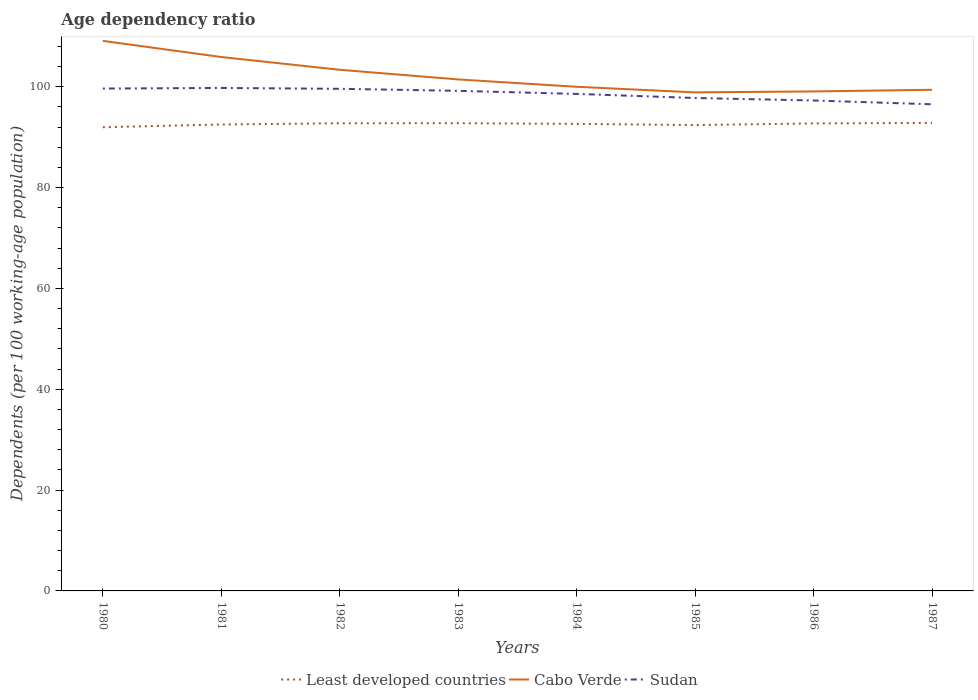How many different coloured lines are there?
Your response must be concise. 3. Across all years, what is the maximum age dependency ratio in in Cabo Verde?
Keep it short and to the point. 98.88. What is the total age dependency ratio in in Cabo Verde in the graph?
Your answer should be very brief. 1.91. What is the difference between the highest and the second highest age dependency ratio in in Least developed countries?
Your answer should be compact. 0.85. What is the difference between the highest and the lowest age dependency ratio in in Sudan?
Provide a short and direct response. 5. Is the age dependency ratio in in Sudan strictly greater than the age dependency ratio in in Least developed countries over the years?
Your answer should be compact. No. Are the values on the major ticks of Y-axis written in scientific E-notation?
Make the answer very short. No. Where does the legend appear in the graph?
Provide a succinct answer. Bottom center. How many legend labels are there?
Your response must be concise. 3. What is the title of the graph?
Ensure brevity in your answer.  Age dependency ratio. Does "Isle of Man" appear as one of the legend labels in the graph?
Your answer should be very brief. No. What is the label or title of the X-axis?
Make the answer very short. Years. What is the label or title of the Y-axis?
Keep it short and to the point. Dependents (per 100 working-age population). What is the Dependents (per 100 working-age population) in Least developed countries in 1980?
Ensure brevity in your answer.  91.97. What is the Dependents (per 100 working-age population) in Cabo Verde in 1980?
Make the answer very short. 109.09. What is the Dependents (per 100 working-age population) in Sudan in 1980?
Your answer should be very brief. 99.63. What is the Dependents (per 100 working-age population) of Least developed countries in 1981?
Keep it short and to the point. 92.51. What is the Dependents (per 100 working-age population) of Cabo Verde in 1981?
Ensure brevity in your answer.  105.89. What is the Dependents (per 100 working-age population) in Sudan in 1981?
Provide a short and direct response. 99.75. What is the Dependents (per 100 working-age population) of Least developed countries in 1982?
Your answer should be very brief. 92.75. What is the Dependents (per 100 working-age population) of Cabo Verde in 1982?
Make the answer very short. 103.36. What is the Dependents (per 100 working-age population) of Sudan in 1982?
Keep it short and to the point. 99.58. What is the Dependents (per 100 working-age population) in Least developed countries in 1983?
Your answer should be compact. 92.76. What is the Dependents (per 100 working-age population) of Cabo Verde in 1983?
Keep it short and to the point. 101.44. What is the Dependents (per 100 working-age population) in Sudan in 1983?
Make the answer very short. 99.18. What is the Dependents (per 100 working-age population) in Least developed countries in 1984?
Your response must be concise. 92.63. What is the Dependents (per 100 working-age population) of Cabo Verde in 1984?
Your answer should be compact. 99.98. What is the Dependents (per 100 working-age population) in Sudan in 1984?
Your answer should be very brief. 98.57. What is the Dependents (per 100 working-age population) in Least developed countries in 1985?
Keep it short and to the point. 92.39. What is the Dependents (per 100 working-age population) of Cabo Verde in 1985?
Offer a terse response. 98.88. What is the Dependents (per 100 working-age population) in Sudan in 1985?
Ensure brevity in your answer.  97.76. What is the Dependents (per 100 working-age population) of Least developed countries in 1986?
Your answer should be very brief. 92.72. What is the Dependents (per 100 working-age population) of Cabo Verde in 1986?
Offer a terse response. 99.06. What is the Dependents (per 100 working-age population) of Sudan in 1986?
Offer a terse response. 97.27. What is the Dependents (per 100 working-age population) in Least developed countries in 1987?
Make the answer very short. 92.81. What is the Dependents (per 100 working-age population) of Cabo Verde in 1987?
Your response must be concise. 99.39. What is the Dependents (per 100 working-age population) in Sudan in 1987?
Provide a short and direct response. 96.52. Across all years, what is the maximum Dependents (per 100 working-age population) in Least developed countries?
Provide a short and direct response. 92.81. Across all years, what is the maximum Dependents (per 100 working-age population) in Cabo Verde?
Your response must be concise. 109.09. Across all years, what is the maximum Dependents (per 100 working-age population) of Sudan?
Make the answer very short. 99.75. Across all years, what is the minimum Dependents (per 100 working-age population) in Least developed countries?
Your answer should be very brief. 91.97. Across all years, what is the minimum Dependents (per 100 working-age population) in Cabo Verde?
Offer a terse response. 98.88. Across all years, what is the minimum Dependents (per 100 working-age population) in Sudan?
Ensure brevity in your answer.  96.52. What is the total Dependents (per 100 working-age population) in Least developed countries in the graph?
Your answer should be compact. 740.54. What is the total Dependents (per 100 working-age population) in Cabo Verde in the graph?
Offer a very short reply. 817.08. What is the total Dependents (per 100 working-age population) in Sudan in the graph?
Your response must be concise. 788.27. What is the difference between the Dependents (per 100 working-age population) of Least developed countries in 1980 and that in 1981?
Your response must be concise. -0.54. What is the difference between the Dependents (per 100 working-age population) in Cabo Verde in 1980 and that in 1981?
Offer a very short reply. 3.2. What is the difference between the Dependents (per 100 working-age population) in Sudan in 1980 and that in 1981?
Your response must be concise. -0.12. What is the difference between the Dependents (per 100 working-age population) in Least developed countries in 1980 and that in 1982?
Provide a succinct answer. -0.78. What is the difference between the Dependents (per 100 working-age population) in Cabo Verde in 1980 and that in 1982?
Offer a very short reply. 5.73. What is the difference between the Dependents (per 100 working-age population) in Sudan in 1980 and that in 1982?
Provide a succinct answer. 0.05. What is the difference between the Dependents (per 100 working-age population) in Least developed countries in 1980 and that in 1983?
Give a very brief answer. -0.8. What is the difference between the Dependents (per 100 working-age population) of Cabo Verde in 1980 and that in 1983?
Make the answer very short. 7.64. What is the difference between the Dependents (per 100 working-age population) of Sudan in 1980 and that in 1983?
Provide a succinct answer. 0.45. What is the difference between the Dependents (per 100 working-age population) in Least developed countries in 1980 and that in 1984?
Ensure brevity in your answer.  -0.66. What is the difference between the Dependents (per 100 working-age population) in Cabo Verde in 1980 and that in 1984?
Your answer should be compact. 9.1. What is the difference between the Dependents (per 100 working-age population) of Sudan in 1980 and that in 1984?
Ensure brevity in your answer.  1.06. What is the difference between the Dependents (per 100 working-age population) in Least developed countries in 1980 and that in 1985?
Your answer should be compact. -0.43. What is the difference between the Dependents (per 100 working-age population) in Cabo Verde in 1980 and that in 1985?
Keep it short and to the point. 10.21. What is the difference between the Dependents (per 100 working-age population) in Sudan in 1980 and that in 1985?
Ensure brevity in your answer.  1.87. What is the difference between the Dependents (per 100 working-age population) in Least developed countries in 1980 and that in 1986?
Give a very brief answer. -0.75. What is the difference between the Dependents (per 100 working-age population) in Cabo Verde in 1980 and that in 1986?
Your answer should be very brief. 10.03. What is the difference between the Dependents (per 100 working-age population) of Sudan in 1980 and that in 1986?
Your response must be concise. 2.37. What is the difference between the Dependents (per 100 working-age population) of Least developed countries in 1980 and that in 1987?
Your answer should be compact. -0.85. What is the difference between the Dependents (per 100 working-age population) of Cabo Verde in 1980 and that in 1987?
Provide a succinct answer. 9.7. What is the difference between the Dependents (per 100 working-age population) in Sudan in 1980 and that in 1987?
Provide a succinct answer. 3.12. What is the difference between the Dependents (per 100 working-age population) of Least developed countries in 1981 and that in 1982?
Keep it short and to the point. -0.24. What is the difference between the Dependents (per 100 working-age population) of Cabo Verde in 1981 and that in 1982?
Provide a short and direct response. 2.53. What is the difference between the Dependents (per 100 working-age population) of Sudan in 1981 and that in 1982?
Give a very brief answer. 0.17. What is the difference between the Dependents (per 100 working-age population) of Least developed countries in 1981 and that in 1983?
Offer a very short reply. -0.26. What is the difference between the Dependents (per 100 working-age population) of Cabo Verde in 1981 and that in 1983?
Your answer should be very brief. 4.44. What is the difference between the Dependents (per 100 working-age population) of Sudan in 1981 and that in 1983?
Offer a terse response. 0.57. What is the difference between the Dependents (per 100 working-age population) in Least developed countries in 1981 and that in 1984?
Provide a succinct answer. -0.12. What is the difference between the Dependents (per 100 working-age population) in Cabo Verde in 1981 and that in 1984?
Your answer should be very brief. 5.9. What is the difference between the Dependents (per 100 working-age population) in Sudan in 1981 and that in 1984?
Your answer should be very brief. 1.18. What is the difference between the Dependents (per 100 working-age population) of Least developed countries in 1981 and that in 1985?
Ensure brevity in your answer.  0.11. What is the difference between the Dependents (per 100 working-age population) of Cabo Verde in 1981 and that in 1985?
Keep it short and to the point. 7.01. What is the difference between the Dependents (per 100 working-age population) of Sudan in 1981 and that in 1985?
Keep it short and to the point. 1.99. What is the difference between the Dependents (per 100 working-age population) in Least developed countries in 1981 and that in 1986?
Your answer should be very brief. -0.21. What is the difference between the Dependents (per 100 working-age population) in Cabo Verde in 1981 and that in 1986?
Keep it short and to the point. 6.83. What is the difference between the Dependents (per 100 working-age population) in Sudan in 1981 and that in 1986?
Provide a short and direct response. 2.49. What is the difference between the Dependents (per 100 working-age population) in Least developed countries in 1981 and that in 1987?
Provide a succinct answer. -0.31. What is the difference between the Dependents (per 100 working-age population) of Cabo Verde in 1981 and that in 1987?
Your answer should be compact. 6.5. What is the difference between the Dependents (per 100 working-age population) of Sudan in 1981 and that in 1987?
Ensure brevity in your answer.  3.24. What is the difference between the Dependents (per 100 working-age population) of Least developed countries in 1982 and that in 1983?
Give a very brief answer. -0.01. What is the difference between the Dependents (per 100 working-age population) in Cabo Verde in 1982 and that in 1983?
Your answer should be compact. 1.91. What is the difference between the Dependents (per 100 working-age population) of Sudan in 1982 and that in 1983?
Provide a succinct answer. 0.4. What is the difference between the Dependents (per 100 working-age population) of Least developed countries in 1982 and that in 1984?
Give a very brief answer. 0.12. What is the difference between the Dependents (per 100 working-age population) in Cabo Verde in 1982 and that in 1984?
Offer a very short reply. 3.37. What is the difference between the Dependents (per 100 working-age population) of Sudan in 1982 and that in 1984?
Your answer should be very brief. 1.01. What is the difference between the Dependents (per 100 working-age population) in Least developed countries in 1982 and that in 1985?
Keep it short and to the point. 0.35. What is the difference between the Dependents (per 100 working-age population) of Cabo Verde in 1982 and that in 1985?
Make the answer very short. 4.48. What is the difference between the Dependents (per 100 working-age population) of Sudan in 1982 and that in 1985?
Your answer should be very brief. 1.82. What is the difference between the Dependents (per 100 working-age population) in Least developed countries in 1982 and that in 1986?
Ensure brevity in your answer.  0.03. What is the difference between the Dependents (per 100 working-age population) in Cabo Verde in 1982 and that in 1986?
Ensure brevity in your answer.  4.3. What is the difference between the Dependents (per 100 working-age population) in Sudan in 1982 and that in 1986?
Give a very brief answer. 2.32. What is the difference between the Dependents (per 100 working-age population) in Least developed countries in 1982 and that in 1987?
Provide a succinct answer. -0.07. What is the difference between the Dependents (per 100 working-age population) of Cabo Verde in 1982 and that in 1987?
Offer a very short reply. 3.97. What is the difference between the Dependents (per 100 working-age population) of Sudan in 1982 and that in 1987?
Your answer should be compact. 3.07. What is the difference between the Dependents (per 100 working-age population) in Least developed countries in 1983 and that in 1984?
Ensure brevity in your answer.  0.13. What is the difference between the Dependents (per 100 working-age population) in Cabo Verde in 1983 and that in 1984?
Make the answer very short. 1.46. What is the difference between the Dependents (per 100 working-age population) of Sudan in 1983 and that in 1984?
Your answer should be compact. 0.61. What is the difference between the Dependents (per 100 working-age population) of Least developed countries in 1983 and that in 1985?
Offer a terse response. 0.37. What is the difference between the Dependents (per 100 working-age population) in Cabo Verde in 1983 and that in 1985?
Your answer should be very brief. 2.57. What is the difference between the Dependents (per 100 working-age population) in Sudan in 1983 and that in 1985?
Provide a succinct answer. 1.42. What is the difference between the Dependents (per 100 working-age population) of Least developed countries in 1983 and that in 1986?
Your answer should be very brief. 0.04. What is the difference between the Dependents (per 100 working-age population) of Cabo Verde in 1983 and that in 1986?
Offer a terse response. 2.38. What is the difference between the Dependents (per 100 working-age population) of Sudan in 1983 and that in 1986?
Give a very brief answer. 1.91. What is the difference between the Dependents (per 100 working-age population) of Least developed countries in 1983 and that in 1987?
Provide a short and direct response. -0.05. What is the difference between the Dependents (per 100 working-age population) in Cabo Verde in 1983 and that in 1987?
Make the answer very short. 2.05. What is the difference between the Dependents (per 100 working-age population) of Sudan in 1983 and that in 1987?
Ensure brevity in your answer.  2.66. What is the difference between the Dependents (per 100 working-age population) of Least developed countries in 1984 and that in 1985?
Your answer should be compact. 0.24. What is the difference between the Dependents (per 100 working-age population) in Cabo Verde in 1984 and that in 1985?
Your response must be concise. 1.11. What is the difference between the Dependents (per 100 working-age population) in Sudan in 1984 and that in 1985?
Give a very brief answer. 0.81. What is the difference between the Dependents (per 100 working-age population) of Least developed countries in 1984 and that in 1986?
Offer a terse response. -0.09. What is the difference between the Dependents (per 100 working-age population) of Cabo Verde in 1984 and that in 1986?
Keep it short and to the point. 0.92. What is the difference between the Dependents (per 100 working-age population) in Sudan in 1984 and that in 1986?
Provide a succinct answer. 1.3. What is the difference between the Dependents (per 100 working-age population) in Least developed countries in 1984 and that in 1987?
Provide a succinct answer. -0.19. What is the difference between the Dependents (per 100 working-age population) in Cabo Verde in 1984 and that in 1987?
Keep it short and to the point. 0.59. What is the difference between the Dependents (per 100 working-age population) in Sudan in 1984 and that in 1987?
Provide a short and direct response. 2.05. What is the difference between the Dependents (per 100 working-age population) in Least developed countries in 1985 and that in 1986?
Offer a very short reply. -0.33. What is the difference between the Dependents (per 100 working-age population) of Cabo Verde in 1985 and that in 1986?
Provide a short and direct response. -0.18. What is the difference between the Dependents (per 100 working-age population) of Sudan in 1985 and that in 1986?
Provide a short and direct response. 0.5. What is the difference between the Dependents (per 100 working-age population) in Least developed countries in 1985 and that in 1987?
Your answer should be compact. -0.42. What is the difference between the Dependents (per 100 working-age population) of Cabo Verde in 1985 and that in 1987?
Your answer should be compact. -0.51. What is the difference between the Dependents (per 100 working-age population) of Sudan in 1985 and that in 1987?
Provide a short and direct response. 1.25. What is the difference between the Dependents (per 100 working-age population) of Least developed countries in 1986 and that in 1987?
Offer a terse response. -0.1. What is the difference between the Dependents (per 100 working-age population) of Cabo Verde in 1986 and that in 1987?
Provide a short and direct response. -0.33. What is the difference between the Dependents (per 100 working-age population) of Sudan in 1986 and that in 1987?
Provide a succinct answer. 0.75. What is the difference between the Dependents (per 100 working-age population) of Least developed countries in 1980 and the Dependents (per 100 working-age population) of Cabo Verde in 1981?
Your answer should be very brief. -13.92. What is the difference between the Dependents (per 100 working-age population) in Least developed countries in 1980 and the Dependents (per 100 working-age population) in Sudan in 1981?
Ensure brevity in your answer.  -7.79. What is the difference between the Dependents (per 100 working-age population) in Cabo Verde in 1980 and the Dependents (per 100 working-age population) in Sudan in 1981?
Make the answer very short. 9.33. What is the difference between the Dependents (per 100 working-age population) in Least developed countries in 1980 and the Dependents (per 100 working-age population) in Cabo Verde in 1982?
Offer a terse response. -11.39. What is the difference between the Dependents (per 100 working-age population) of Least developed countries in 1980 and the Dependents (per 100 working-age population) of Sudan in 1982?
Your answer should be compact. -7.62. What is the difference between the Dependents (per 100 working-age population) in Cabo Verde in 1980 and the Dependents (per 100 working-age population) in Sudan in 1982?
Give a very brief answer. 9.5. What is the difference between the Dependents (per 100 working-age population) in Least developed countries in 1980 and the Dependents (per 100 working-age population) in Cabo Verde in 1983?
Your response must be concise. -9.48. What is the difference between the Dependents (per 100 working-age population) of Least developed countries in 1980 and the Dependents (per 100 working-age population) of Sudan in 1983?
Keep it short and to the point. -7.21. What is the difference between the Dependents (per 100 working-age population) in Cabo Verde in 1980 and the Dependents (per 100 working-age population) in Sudan in 1983?
Offer a terse response. 9.91. What is the difference between the Dependents (per 100 working-age population) in Least developed countries in 1980 and the Dependents (per 100 working-age population) in Cabo Verde in 1984?
Keep it short and to the point. -8.02. What is the difference between the Dependents (per 100 working-age population) in Least developed countries in 1980 and the Dependents (per 100 working-age population) in Sudan in 1984?
Offer a very short reply. -6.6. What is the difference between the Dependents (per 100 working-age population) of Cabo Verde in 1980 and the Dependents (per 100 working-age population) of Sudan in 1984?
Make the answer very short. 10.52. What is the difference between the Dependents (per 100 working-age population) of Least developed countries in 1980 and the Dependents (per 100 working-age population) of Cabo Verde in 1985?
Provide a short and direct response. -6.91. What is the difference between the Dependents (per 100 working-age population) of Least developed countries in 1980 and the Dependents (per 100 working-age population) of Sudan in 1985?
Give a very brief answer. -5.8. What is the difference between the Dependents (per 100 working-age population) of Cabo Verde in 1980 and the Dependents (per 100 working-age population) of Sudan in 1985?
Your answer should be compact. 11.32. What is the difference between the Dependents (per 100 working-age population) of Least developed countries in 1980 and the Dependents (per 100 working-age population) of Cabo Verde in 1986?
Ensure brevity in your answer.  -7.09. What is the difference between the Dependents (per 100 working-age population) of Least developed countries in 1980 and the Dependents (per 100 working-age population) of Sudan in 1986?
Your answer should be very brief. -5.3. What is the difference between the Dependents (per 100 working-age population) of Cabo Verde in 1980 and the Dependents (per 100 working-age population) of Sudan in 1986?
Provide a succinct answer. 11.82. What is the difference between the Dependents (per 100 working-age population) in Least developed countries in 1980 and the Dependents (per 100 working-age population) in Cabo Verde in 1987?
Offer a very short reply. -7.42. What is the difference between the Dependents (per 100 working-age population) in Least developed countries in 1980 and the Dependents (per 100 working-age population) in Sudan in 1987?
Provide a succinct answer. -4.55. What is the difference between the Dependents (per 100 working-age population) of Cabo Verde in 1980 and the Dependents (per 100 working-age population) of Sudan in 1987?
Provide a short and direct response. 12.57. What is the difference between the Dependents (per 100 working-age population) in Least developed countries in 1981 and the Dependents (per 100 working-age population) in Cabo Verde in 1982?
Your answer should be compact. -10.85. What is the difference between the Dependents (per 100 working-age population) in Least developed countries in 1981 and the Dependents (per 100 working-age population) in Sudan in 1982?
Your response must be concise. -7.08. What is the difference between the Dependents (per 100 working-age population) of Cabo Verde in 1981 and the Dependents (per 100 working-age population) of Sudan in 1982?
Keep it short and to the point. 6.3. What is the difference between the Dependents (per 100 working-age population) of Least developed countries in 1981 and the Dependents (per 100 working-age population) of Cabo Verde in 1983?
Give a very brief answer. -8.94. What is the difference between the Dependents (per 100 working-age population) of Least developed countries in 1981 and the Dependents (per 100 working-age population) of Sudan in 1983?
Your answer should be very brief. -6.67. What is the difference between the Dependents (per 100 working-age population) of Cabo Verde in 1981 and the Dependents (per 100 working-age population) of Sudan in 1983?
Ensure brevity in your answer.  6.71. What is the difference between the Dependents (per 100 working-age population) of Least developed countries in 1981 and the Dependents (per 100 working-age population) of Cabo Verde in 1984?
Keep it short and to the point. -7.47. What is the difference between the Dependents (per 100 working-age population) in Least developed countries in 1981 and the Dependents (per 100 working-age population) in Sudan in 1984?
Offer a terse response. -6.06. What is the difference between the Dependents (per 100 working-age population) of Cabo Verde in 1981 and the Dependents (per 100 working-age population) of Sudan in 1984?
Offer a very short reply. 7.32. What is the difference between the Dependents (per 100 working-age population) in Least developed countries in 1981 and the Dependents (per 100 working-age population) in Cabo Verde in 1985?
Provide a succinct answer. -6.37. What is the difference between the Dependents (per 100 working-age population) in Least developed countries in 1981 and the Dependents (per 100 working-age population) in Sudan in 1985?
Keep it short and to the point. -5.25. What is the difference between the Dependents (per 100 working-age population) in Cabo Verde in 1981 and the Dependents (per 100 working-age population) in Sudan in 1985?
Your response must be concise. 8.13. What is the difference between the Dependents (per 100 working-age population) in Least developed countries in 1981 and the Dependents (per 100 working-age population) in Cabo Verde in 1986?
Your answer should be very brief. -6.55. What is the difference between the Dependents (per 100 working-age population) of Least developed countries in 1981 and the Dependents (per 100 working-age population) of Sudan in 1986?
Offer a terse response. -4.76. What is the difference between the Dependents (per 100 working-age population) of Cabo Verde in 1981 and the Dependents (per 100 working-age population) of Sudan in 1986?
Offer a very short reply. 8.62. What is the difference between the Dependents (per 100 working-age population) of Least developed countries in 1981 and the Dependents (per 100 working-age population) of Cabo Verde in 1987?
Make the answer very short. -6.88. What is the difference between the Dependents (per 100 working-age population) in Least developed countries in 1981 and the Dependents (per 100 working-age population) in Sudan in 1987?
Your answer should be compact. -4.01. What is the difference between the Dependents (per 100 working-age population) in Cabo Verde in 1981 and the Dependents (per 100 working-age population) in Sudan in 1987?
Give a very brief answer. 9.37. What is the difference between the Dependents (per 100 working-age population) in Least developed countries in 1982 and the Dependents (per 100 working-age population) in Cabo Verde in 1983?
Your response must be concise. -8.69. What is the difference between the Dependents (per 100 working-age population) in Least developed countries in 1982 and the Dependents (per 100 working-age population) in Sudan in 1983?
Provide a short and direct response. -6.43. What is the difference between the Dependents (per 100 working-age population) of Cabo Verde in 1982 and the Dependents (per 100 working-age population) of Sudan in 1983?
Provide a succinct answer. 4.17. What is the difference between the Dependents (per 100 working-age population) of Least developed countries in 1982 and the Dependents (per 100 working-age population) of Cabo Verde in 1984?
Keep it short and to the point. -7.23. What is the difference between the Dependents (per 100 working-age population) in Least developed countries in 1982 and the Dependents (per 100 working-age population) in Sudan in 1984?
Your answer should be very brief. -5.82. What is the difference between the Dependents (per 100 working-age population) in Cabo Verde in 1982 and the Dependents (per 100 working-age population) in Sudan in 1984?
Offer a very short reply. 4.79. What is the difference between the Dependents (per 100 working-age population) of Least developed countries in 1982 and the Dependents (per 100 working-age population) of Cabo Verde in 1985?
Make the answer very short. -6.13. What is the difference between the Dependents (per 100 working-age population) of Least developed countries in 1982 and the Dependents (per 100 working-age population) of Sudan in 1985?
Ensure brevity in your answer.  -5.01. What is the difference between the Dependents (per 100 working-age population) of Cabo Verde in 1982 and the Dependents (per 100 working-age population) of Sudan in 1985?
Make the answer very short. 5.59. What is the difference between the Dependents (per 100 working-age population) of Least developed countries in 1982 and the Dependents (per 100 working-age population) of Cabo Verde in 1986?
Provide a short and direct response. -6.31. What is the difference between the Dependents (per 100 working-age population) in Least developed countries in 1982 and the Dependents (per 100 working-age population) in Sudan in 1986?
Your response must be concise. -4.52. What is the difference between the Dependents (per 100 working-age population) of Cabo Verde in 1982 and the Dependents (per 100 working-age population) of Sudan in 1986?
Give a very brief answer. 6.09. What is the difference between the Dependents (per 100 working-age population) of Least developed countries in 1982 and the Dependents (per 100 working-age population) of Cabo Verde in 1987?
Keep it short and to the point. -6.64. What is the difference between the Dependents (per 100 working-age population) in Least developed countries in 1982 and the Dependents (per 100 working-age population) in Sudan in 1987?
Give a very brief answer. -3.77. What is the difference between the Dependents (per 100 working-age population) of Cabo Verde in 1982 and the Dependents (per 100 working-age population) of Sudan in 1987?
Your response must be concise. 6.84. What is the difference between the Dependents (per 100 working-age population) of Least developed countries in 1983 and the Dependents (per 100 working-age population) of Cabo Verde in 1984?
Provide a short and direct response. -7.22. What is the difference between the Dependents (per 100 working-age population) in Least developed countries in 1983 and the Dependents (per 100 working-age population) in Sudan in 1984?
Your answer should be compact. -5.81. What is the difference between the Dependents (per 100 working-age population) in Cabo Verde in 1983 and the Dependents (per 100 working-age population) in Sudan in 1984?
Ensure brevity in your answer.  2.87. What is the difference between the Dependents (per 100 working-age population) of Least developed countries in 1983 and the Dependents (per 100 working-age population) of Cabo Verde in 1985?
Your answer should be very brief. -6.11. What is the difference between the Dependents (per 100 working-age population) of Least developed countries in 1983 and the Dependents (per 100 working-age population) of Sudan in 1985?
Offer a very short reply. -5. What is the difference between the Dependents (per 100 working-age population) of Cabo Verde in 1983 and the Dependents (per 100 working-age population) of Sudan in 1985?
Provide a short and direct response. 3.68. What is the difference between the Dependents (per 100 working-age population) of Least developed countries in 1983 and the Dependents (per 100 working-age population) of Cabo Verde in 1986?
Offer a very short reply. -6.3. What is the difference between the Dependents (per 100 working-age population) in Least developed countries in 1983 and the Dependents (per 100 working-age population) in Sudan in 1986?
Provide a short and direct response. -4.5. What is the difference between the Dependents (per 100 working-age population) in Cabo Verde in 1983 and the Dependents (per 100 working-age population) in Sudan in 1986?
Provide a succinct answer. 4.18. What is the difference between the Dependents (per 100 working-age population) in Least developed countries in 1983 and the Dependents (per 100 working-age population) in Cabo Verde in 1987?
Make the answer very short. -6.63. What is the difference between the Dependents (per 100 working-age population) in Least developed countries in 1983 and the Dependents (per 100 working-age population) in Sudan in 1987?
Keep it short and to the point. -3.75. What is the difference between the Dependents (per 100 working-age population) in Cabo Verde in 1983 and the Dependents (per 100 working-age population) in Sudan in 1987?
Keep it short and to the point. 4.93. What is the difference between the Dependents (per 100 working-age population) of Least developed countries in 1984 and the Dependents (per 100 working-age population) of Cabo Verde in 1985?
Keep it short and to the point. -6.25. What is the difference between the Dependents (per 100 working-age population) of Least developed countries in 1984 and the Dependents (per 100 working-age population) of Sudan in 1985?
Your answer should be very brief. -5.13. What is the difference between the Dependents (per 100 working-age population) in Cabo Verde in 1984 and the Dependents (per 100 working-age population) in Sudan in 1985?
Your answer should be very brief. 2.22. What is the difference between the Dependents (per 100 working-age population) of Least developed countries in 1984 and the Dependents (per 100 working-age population) of Cabo Verde in 1986?
Your answer should be very brief. -6.43. What is the difference between the Dependents (per 100 working-age population) of Least developed countries in 1984 and the Dependents (per 100 working-age population) of Sudan in 1986?
Give a very brief answer. -4.64. What is the difference between the Dependents (per 100 working-age population) in Cabo Verde in 1984 and the Dependents (per 100 working-age population) in Sudan in 1986?
Your answer should be very brief. 2.72. What is the difference between the Dependents (per 100 working-age population) of Least developed countries in 1984 and the Dependents (per 100 working-age population) of Cabo Verde in 1987?
Give a very brief answer. -6.76. What is the difference between the Dependents (per 100 working-age population) in Least developed countries in 1984 and the Dependents (per 100 working-age population) in Sudan in 1987?
Provide a short and direct response. -3.89. What is the difference between the Dependents (per 100 working-age population) of Cabo Verde in 1984 and the Dependents (per 100 working-age population) of Sudan in 1987?
Your answer should be very brief. 3.47. What is the difference between the Dependents (per 100 working-age population) of Least developed countries in 1985 and the Dependents (per 100 working-age population) of Cabo Verde in 1986?
Your response must be concise. -6.67. What is the difference between the Dependents (per 100 working-age population) in Least developed countries in 1985 and the Dependents (per 100 working-age population) in Sudan in 1986?
Make the answer very short. -4.87. What is the difference between the Dependents (per 100 working-age population) in Cabo Verde in 1985 and the Dependents (per 100 working-age population) in Sudan in 1986?
Offer a very short reply. 1.61. What is the difference between the Dependents (per 100 working-age population) of Least developed countries in 1985 and the Dependents (per 100 working-age population) of Cabo Verde in 1987?
Offer a very short reply. -7. What is the difference between the Dependents (per 100 working-age population) of Least developed countries in 1985 and the Dependents (per 100 working-age population) of Sudan in 1987?
Offer a terse response. -4.12. What is the difference between the Dependents (per 100 working-age population) of Cabo Verde in 1985 and the Dependents (per 100 working-age population) of Sudan in 1987?
Keep it short and to the point. 2.36. What is the difference between the Dependents (per 100 working-age population) of Least developed countries in 1986 and the Dependents (per 100 working-age population) of Cabo Verde in 1987?
Your answer should be compact. -6.67. What is the difference between the Dependents (per 100 working-age population) of Least developed countries in 1986 and the Dependents (per 100 working-age population) of Sudan in 1987?
Your answer should be compact. -3.8. What is the difference between the Dependents (per 100 working-age population) of Cabo Verde in 1986 and the Dependents (per 100 working-age population) of Sudan in 1987?
Offer a very short reply. 2.54. What is the average Dependents (per 100 working-age population) of Least developed countries per year?
Provide a succinct answer. 92.57. What is the average Dependents (per 100 working-age population) of Cabo Verde per year?
Your response must be concise. 102.13. What is the average Dependents (per 100 working-age population) in Sudan per year?
Provide a short and direct response. 98.53. In the year 1980, what is the difference between the Dependents (per 100 working-age population) of Least developed countries and Dependents (per 100 working-age population) of Cabo Verde?
Provide a succinct answer. -17.12. In the year 1980, what is the difference between the Dependents (per 100 working-age population) of Least developed countries and Dependents (per 100 working-age population) of Sudan?
Offer a terse response. -7.67. In the year 1980, what is the difference between the Dependents (per 100 working-age population) in Cabo Verde and Dependents (per 100 working-age population) in Sudan?
Your response must be concise. 9.45. In the year 1981, what is the difference between the Dependents (per 100 working-age population) of Least developed countries and Dependents (per 100 working-age population) of Cabo Verde?
Keep it short and to the point. -13.38. In the year 1981, what is the difference between the Dependents (per 100 working-age population) in Least developed countries and Dependents (per 100 working-age population) in Sudan?
Your answer should be very brief. -7.24. In the year 1981, what is the difference between the Dependents (per 100 working-age population) in Cabo Verde and Dependents (per 100 working-age population) in Sudan?
Keep it short and to the point. 6.13. In the year 1982, what is the difference between the Dependents (per 100 working-age population) in Least developed countries and Dependents (per 100 working-age population) in Cabo Verde?
Your response must be concise. -10.61. In the year 1982, what is the difference between the Dependents (per 100 working-age population) of Least developed countries and Dependents (per 100 working-age population) of Sudan?
Give a very brief answer. -6.84. In the year 1982, what is the difference between the Dependents (per 100 working-age population) of Cabo Verde and Dependents (per 100 working-age population) of Sudan?
Offer a terse response. 3.77. In the year 1983, what is the difference between the Dependents (per 100 working-age population) in Least developed countries and Dependents (per 100 working-age population) in Cabo Verde?
Keep it short and to the point. -8.68. In the year 1983, what is the difference between the Dependents (per 100 working-age population) of Least developed countries and Dependents (per 100 working-age population) of Sudan?
Provide a succinct answer. -6.42. In the year 1983, what is the difference between the Dependents (per 100 working-age population) of Cabo Verde and Dependents (per 100 working-age population) of Sudan?
Provide a succinct answer. 2.26. In the year 1984, what is the difference between the Dependents (per 100 working-age population) of Least developed countries and Dependents (per 100 working-age population) of Cabo Verde?
Your answer should be compact. -7.35. In the year 1984, what is the difference between the Dependents (per 100 working-age population) in Least developed countries and Dependents (per 100 working-age population) in Sudan?
Your answer should be very brief. -5.94. In the year 1984, what is the difference between the Dependents (per 100 working-age population) in Cabo Verde and Dependents (per 100 working-age population) in Sudan?
Provide a succinct answer. 1.41. In the year 1985, what is the difference between the Dependents (per 100 working-age population) in Least developed countries and Dependents (per 100 working-age population) in Cabo Verde?
Your answer should be compact. -6.48. In the year 1985, what is the difference between the Dependents (per 100 working-age population) of Least developed countries and Dependents (per 100 working-age population) of Sudan?
Offer a terse response. -5.37. In the year 1985, what is the difference between the Dependents (per 100 working-age population) in Cabo Verde and Dependents (per 100 working-age population) in Sudan?
Provide a short and direct response. 1.12. In the year 1986, what is the difference between the Dependents (per 100 working-age population) in Least developed countries and Dependents (per 100 working-age population) in Cabo Verde?
Offer a very short reply. -6.34. In the year 1986, what is the difference between the Dependents (per 100 working-age population) of Least developed countries and Dependents (per 100 working-age population) of Sudan?
Keep it short and to the point. -4.55. In the year 1986, what is the difference between the Dependents (per 100 working-age population) of Cabo Verde and Dependents (per 100 working-age population) of Sudan?
Your answer should be compact. 1.79. In the year 1987, what is the difference between the Dependents (per 100 working-age population) in Least developed countries and Dependents (per 100 working-age population) in Cabo Verde?
Provide a short and direct response. -6.57. In the year 1987, what is the difference between the Dependents (per 100 working-age population) in Least developed countries and Dependents (per 100 working-age population) in Sudan?
Give a very brief answer. -3.7. In the year 1987, what is the difference between the Dependents (per 100 working-age population) in Cabo Verde and Dependents (per 100 working-age population) in Sudan?
Provide a short and direct response. 2.87. What is the ratio of the Dependents (per 100 working-age population) in Cabo Verde in 1980 to that in 1981?
Provide a short and direct response. 1.03. What is the ratio of the Dependents (per 100 working-age population) of Sudan in 1980 to that in 1981?
Your answer should be very brief. 1. What is the ratio of the Dependents (per 100 working-age population) in Cabo Verde in 1980 to that in 1982?
Make the answer very short. 1.06. What is the ratio of the Dependents (per 100 working-age population) of Sudan in 1980 to that in 1982?
Offer a terse response. 1. What is the ratio of the Dependents (per 100 working-age population) in Cabo Verde in 1980 to that in 1983?
Offer a terse response. 1.08. What is the ratio of the Dependents (per 100 working-age population) of Sudan in 1980 to that in 1983?
Offer a very short reply. 1. What is the ratio of the Dependents (per 100 working-age population) in Cabo Verde in 1980 to that in 1984?
Keep it short and to the point. 1.09. What is the ratio of the Dependents (per 100 working-age population) of Sudan in 1980 to that in 1984?
Your answer should be compact. 1.01. What is the ratio of the Dependents (per 100 working-age population) of Cabo Verde in 1980 to that in 1985?
Keep it short and to the point. 1.1. What is the ratio of the Dependents (per 100 working-age population) of Sudan in 1980 to that in 1985?
Provide a short and direct response. 1.02. What is the ratio of the Dependents (per 100 working-age population) of Cabo Verde in 1980 to that in 1986?
Make the answer very short. 1.1. What is the ratio of the Dependents (per 100 working-age population) of Sudan in 1980 to that in 1986?
Provide a succinct answer. 1.02. What is the ratio of the Dependents (per 100 working-age population) of Least developed countries in 1980 to that in 1987?
Offer a very short reply. 0.99. What is the ratio of the Dependents (per 100 working-age population) in Cabo Verde in 1980 to that in 1987?
Your answer should be compact. 1.1. What is the ratio of the Dependents (per 100 working-age population) in Sudan in 1980 to that in 1987?
Ensure brevity in your answer.  1.03. What is the ratio of the Dependents (per 100 working-age population) of Least developed countries in 1981 to that in 1982?
Offer a terse response. 1. What is the ratio of the Dependents (per 100 working-age population) of Cabo Verde in 1981 to that in 1982?
Your answer should be compact. 1.02. What is the ratio of the Dependents (per 100 working-age population) in Sudan in 1981 to that in 1982?
Your answer should be very brief. 1. What is the ratio of the Dependents (per 100 working-age population) of Least developed countries in 1981 to that in 1983?
Make the answer very short. 1. What is the ratio of the Dependents (per 100 working-age population) of Cabo Verde in 1981 to that in 1983?
Provide a short and direct response. 1.04. What is the ratio of the Dependents (per 100 working-age population) of Least developed countries in 1981 to that in 1984?
Keep it short and to the point. 1. What is the ratio of the Dependents (per 100 working-age population) of Cabo Verde in 1981 to that in 1984?
Your answer should be very brief. 1.06. What is the ratio of the Dependents (per 100 working-age population) of Sudan in 1981 to that in 1984?
Provide a succinct answer. 1.01. What is the ratio of the Dependents (per 100 working-age population) of Least developed countries in 1981 to that in 1985?
Provide a short and direct response. 1. What is the ratio of the Dependents (per 100 working-age population) of Cabo Verde in 1981 to that in 1985?
Offer a very short reply. 1.07. What is the ratio of the Dependents (per 100 working-age population) of Sudan in 1981 to that in 1985?
Provide a short and direct response. 1.02. What is the ratio of the Dependents (per 100 working-age population) of Cabo Verde in 1981 to that in 1986?
Offer a terse response. 1.07. What is the ratio of the Dependents (per 100 working-age population) in Sudan in 1981 to that in 1986?
Ensure brevity in your answer.  1.03. What is the ratio of the Dependents (per 100 working-age population) in Cabo Verde in 1981 to that in 1987?
Your answer should be very brief. 1.07. What is the ratio of the Dependents (per 100 working-age population) of Sudan in 1981 to that in 1987?
Keep it short and to the point. 1.03. What is the ratio of the Dependents (per 100 working-age population) in Cabo Verde in 1982 to that in 1983?
Ensure brevity in your answer.  1.02. What is the ratio of the Dependents (per 100 working-age population) in Sudan in 1982 to that in 1983?
Provide a succinct answer. 1. What is the ratio of the Dependents (per 100 working-age population) of Least developed countries in 1982 to that in 1984?
Keep it short and to the point. 1. What is the ratio of the Dependents (per 100 working-age population) of Cabo Verde in 1982 to that in 1984?
Your answer should be very brief. 1.03. What is the ratio of the Dependents (per 100 working-age population) of Sudan in 1982 to that in 1984?
Give a very brief answer. 1.01. What is the ratio of the Dependents (per 100 working-age population) of Least developed countries in 1982 to that in 1985?
Give a very brief answer. 1. What is the ratio of the Dependents (per 100 working-age population) of Cabo Verde in 1982 to that in 1985?
Give a very brief answer. 1.05. What is the ratio of the Dependents (per 100 working-age population) of Sudan in 1982 to that in 1985?
Keep it short and to the point. 1.02. What is the ratio of the Dependents (per 100 working-age population) of Cabo Verde in 1982 to that in 1986?
Give a very brief answer. 1.04. What is the ratio of the Dependents (per 100 working-age population) in Sudan in 1982 to that in 1986?
Your answer should be very brief. 1.02. What is the ratio of the Dependents (per 100 working-age population) in Least developed countries in 1982 to that in 1987?
Provide a short and direct response. 1. What is the ratio of the Dependents (per 100 working-age population) in Cabo Verde in 1982 to that in 1987?
Offer a terse response. 1.04. What is the ratio of the Dependents (per 100 working-age population) in Sudan in 1982 to that in 1987?
Give a very brief answer. 1.03. What is the ratio of the Dependents (per 100 working-age population) in Least developed countries in 1983 to that in 1984?
Offer a very short reply. 1. What is the ratio of the Dependents (per 100 working-age population) of Cabo Verde in 1983 to that in 1984?
Your answer should be very brief. 1.01. What is the ratio of the Dependents (per 100 working-age population) in Sudan in 1983 to that in 1984?
Ensure brevity in your answer.  1.01. What is the ratio of the Dependents (per 100 working-age population) of Least developed countries in 1983 to that in 1985?
Offer a very short reply. 1. What is the ratio of the Dependents (per 100 working-age population) of Sudan in 1983 to that in 1985?
Your answer should be very brief. 1.01. What is the ratio of the Dependents (per 100 working-age population) of Least developed countries in 1983 to that in 1986?
Offer a terse response. 1. What is the ratio of the Dependents (per 100 working-age population) of Cabo Verde in 1983 to that in 1986?
Your answer should be very brief. 1.02. What is the ratio of the Dependents (per 100 working-age population) in Sudan in 1983 to that in 1986?
Keep it short and to the point. 1.02. What is the ratio of the Dependents (per 100 working-age population) in Least developed countries in 1983 to that in 1987?
Offer a terse response. 1. What is the ratio of the Dependents (per 100 working-age population) in Cabo Verde in 1983 to that in 1987?
Provide a short and direct response. 1.02. What is the ratio of the Dependents (per 100 working-age population) of Sudan in 1983 to that in 1987?
Your answer should be compact. 1.03. What is the ratio of the Dependents (per 100 working-age population) of Least developed countries in 1984 to that in 1985?
Make the answer very short. 1. What is the ratio of the Dependents (per 100 working-age population) in Cabo Verde in 1984 to that in 1985?
Offer a terse response. 1.01. What is the ratio of the Dependents (per 100 working-age population) of Sudan in 1984 to that in 1985?
Your answer should be compact. 1.01. What is the ratio of the Dependents (per 100 working-age population) in Cabo Verde in 1984 to that in 1986?
Offer a very short reply. 1.01. What is the ratio of the Dependents (per 100 working-age population) in Sudan in 1984 to that in 1986?
Provide a short and direct response. 1.01. What is the ratio of the Dependents (per 100 working-age population) of Cabo Verde in 1984 to that in 1987?
Provide a short and direct response. 1.01. What is the ratio of the Dependents (per 100 working-age population) in Sudan in 1984 to that in 1987?
Offer a terse response. 1.02. What is the ratio of the Dependents (per 100 working-age population) of Cabo Verde in 1985 to that in 1986?
Provide a succinct answer. 1. What is the ratio of the Dependents (per 100 working-age population) of Sudan in 1985 to that in 1986?
Offer a terse response. 1.01. What is the ratio of the Dependents (per 100 working-age population) in Cabo Verde in 1985 to that in 1987?
Your answer should be compact. 0.99. What is the ratio of the Dependents (per 100 working-age population) of Sudan in 1985 to that in 1987?
Your answer should be very brief. 1.01. What is the ratio of the Dependents (per 100 working-age population) in Cabo Verde in 1986 to that in 1987?
Offer a terse response. 1. What is the ratio of the Dependents (per 100 working-age population) in Sudan in 1986 to that in 1987?
Offer a terse response. 1.01. What is the difference between the highest and the second highest Dependents (per 100 working-age population) in Least developed countries?
Ensure brevity in your answer.  0.05. What is the difference between the highest and the second highest Dependents (per 100 working-age population) of Cabo Verde?
Your answer should be very brief. 3.2. What is the difference between the highest and the second highest Dependents (per 100 working-age population) in Sudan?
Your response must be concise. 0.12. What is the difference between the highest and the lowest Dependents (per 100 working-age population) of Least developed countries?
Make the answer very short. 0.85. What is the difference between the highest and the lowest Dependents (per 100 working-age population) of Cabo Verde?
Your answer should be very brief. 10.21. What is the difference between the highest and the lowest Dependents (per 100 working-age population) of Sudan?
Keep it short and to the point. 3.24. 